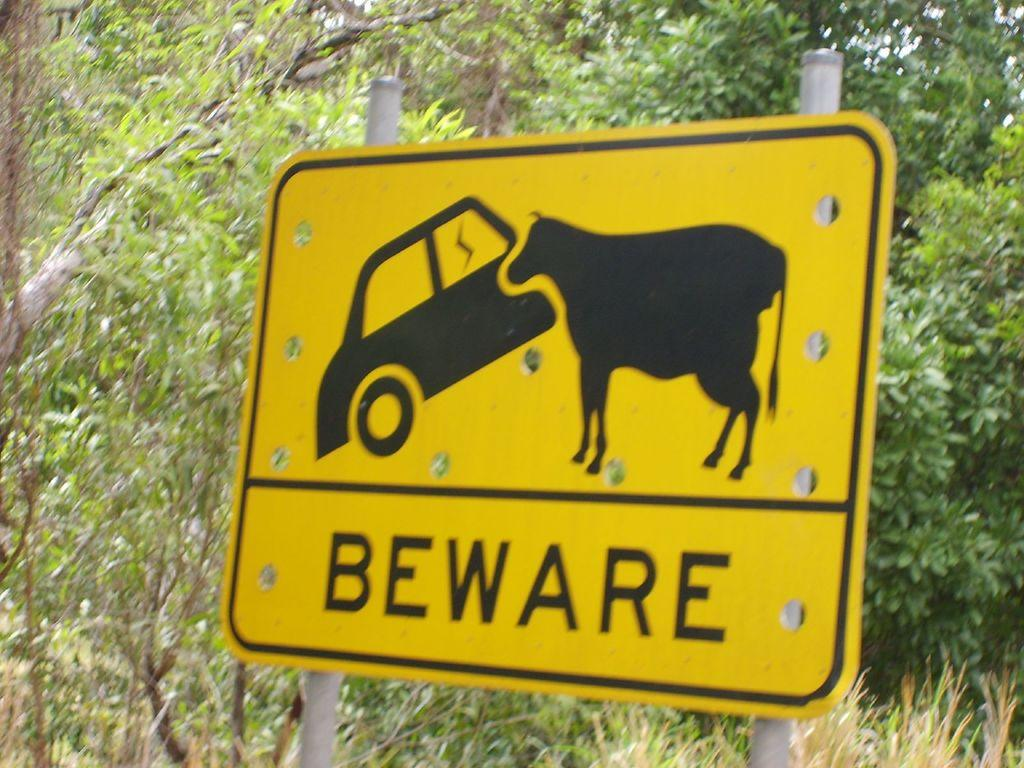What is the color of the sign board in the image? The sign board in the image is yellow. What can be seen behind the sign board? There are trees visible behind the sign board. What type of underwear is hanging on the tree behind the sign board? There is no underwear present in the image; it only features a yellow sign board and trees in the background. 